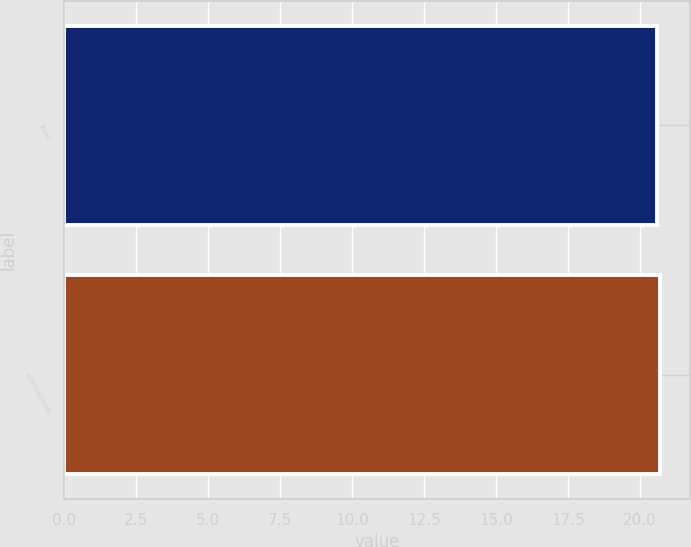<chart> <loc_0><loc_0><loc_500><loc_500><bar_chart><fcel>Total<fcel>International<nl><fcel>20.6<fcel>20.7<nl></chart> 